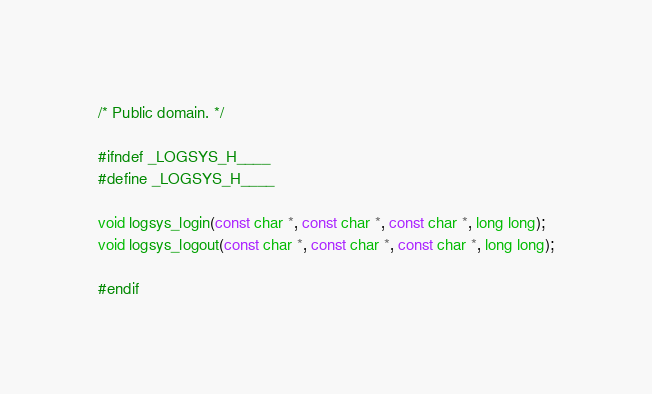<code> <loc_0><loc_0><loc_500><loc_500><_C_>/* Public domain. */

#ifndef _LOGSYS_H____
#define _LOGSYS_H____

void logsys_login(const char *, const char *, const char *, long long);
void logsys_logout(const char *, const char *, const char *, long long);

#endif
</code> 